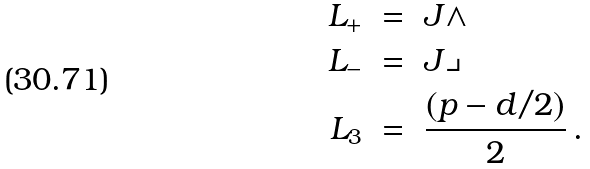Convert formula to latex. <formula><loc_0><loc_0><loc_500><loc_500>L _ { + } \ & = \ J \wedge \\ L _ { - } \ & = \ J \lrcorner \\ L _ { 3 } \ & = \ \frac { ( p - d / 2 ) } { 2 } \, .</formula> 